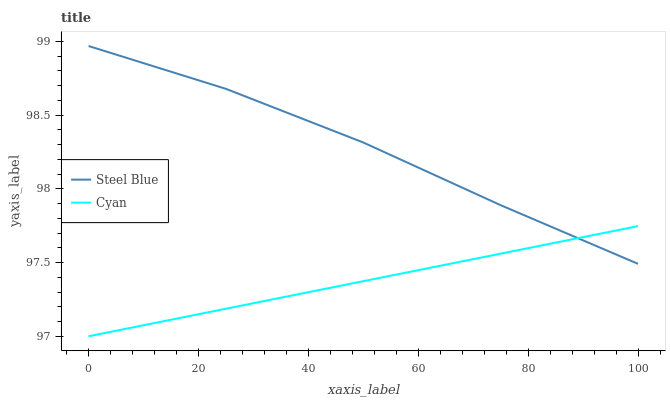Does Cyan have the minimum area under the curve?
Answer yes or no. Yes. Does Steel Blue have the maximum area under the curve?
Answer yes or no. Yes. Does Steel Blue have the minimum area under the curve?
Answer yes or no. No. Is Cyan the smoothest?
Answer yes or no. Yes. Is Steel Blue the roughest?
Answer yes or no. Yes. Is Steel Blue the smoothest?
Answer yes or no. No. Does Steel Blue have the lowest value?
Answer yes or no. No. 